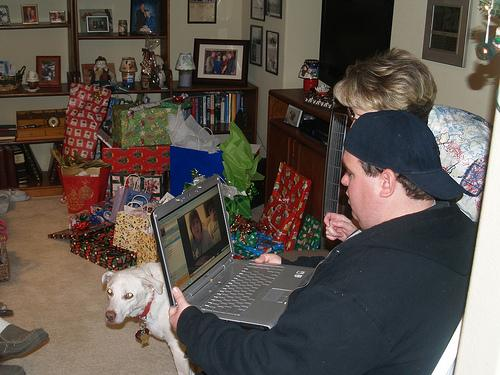Mention the key elements in the image and their interactions. A man in a backwards cap and a woman are sitting on a couch, looking at a laptop on the man's lap, with a white dog wearing a red collar nearby, and a pile of Christmas presents on the floor. Provide an overview of the scene in the image, including the main subjects and their actions. In the image, a man wearing a backwards cap is holding a laptop, with a blonde woman observing, a white dog wearing a red collar is watching, and there are wrapped Christmas presents on the floor. Write a short description of the main subjects in the image and their actions. A man in a backwards cap and a woman look at a laptop on his lap, surrounded by a white dog with a red collar and a pile of Christmas presents. Describe the scene in the image, including any objects or details that stand out. In a cozy living room, a man in a backward cap and a woman are sitting on a couch, examining a laptop. A white dog with a red collar is nearby, and Christmas presents are scattered on the floor. Describe the image's main focal points, including the subjects and their activities. A backwards cap-wearing man and a blonde woman are engaged with a laptop, amidst a white dog in a red collar and a collection of Christmas presents. Describe the main characters in the image and their actions. A man wearing a backwards cap and a sweatshirt holds a laptop, while a blonde woman looks over his shoulder, a white dog with a red collar observes, and stacked Christmas presents lay on the floor. Summarize the main elements and activities occurring in the image. A man in a backward cap and a woman focus on a laptop, while a white dog with a red collar and a pile of Christmas presents share the scene. Explain the primary objects and interactions depicted in the image. The image shows a man with a backwards cap and a blonde woman looking at a laptop, accompanied by a white dog wearing a red collar and a variety of Christmas presents on the floor. Combine the main visual elements of the image into a cohesive description. In a living room, a man with a backwards cap has a laptop on his lap, a blonde woman looks at the laptop, a white dog sits nearby, and Christmas presents are piled on the floor. Briefly summarize the major components of the image and their location. A backwards cap-wearing man and a blonde woman focus on a laptop, while a white dog with a red collar sits close by, and a heap of Christmas presents occupies the floor. Is the dog in the picture wearing a blue collar instead of a red one? No, it's not mentioned in the image. Can you spot the man and woman video chatting with their friends on a tablet? The original information states that the laptop is being used for video chatting, not a tablet. Also, it does not mention any friends. This instruction is misleading as it replaces the laptop with a tablet and introduces new characters. Look for the wedding photo hung on the wall near the framed family picture. The image has framed pictures and a framed family picture, but there's no mention of a wedding photograph on a wall. This instruction introduces a new item that doesn't exist in the given information. Can you find the cat hiding behind the pile of Christmas presents? There is no mention of a cat in the original information, only a white dog. This instruction introduces an entirely new object that is not present in the given image. Find the black dog lying on the beige carpet. The dog in the image is described as white, not black, and the carpet is described as beige but there's no mention of the dog lying on it. This instruction changes the color and position of the dog. 